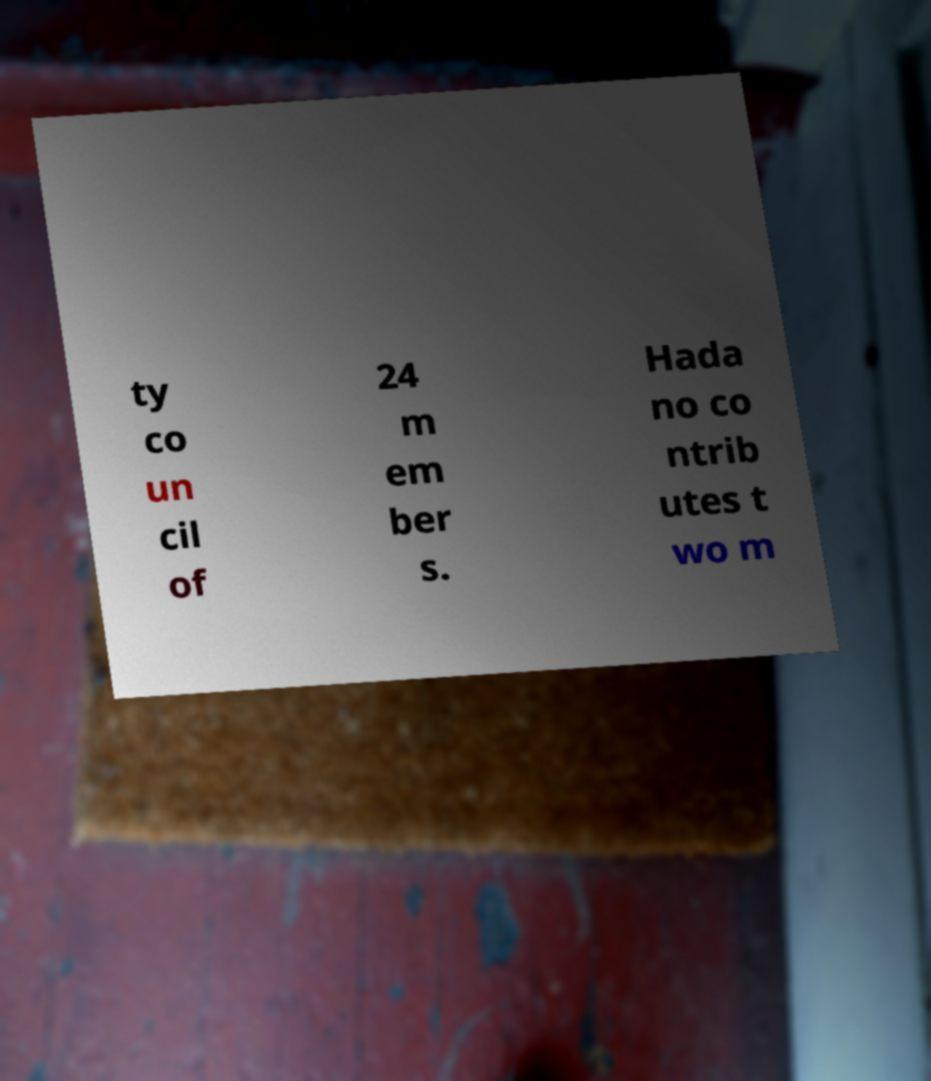There's text embedded in this image that I need extracted. Can you transcribe it verbatim? ty co un cil of 24 m em ber s. Hada no co ntrib utes t wo m 